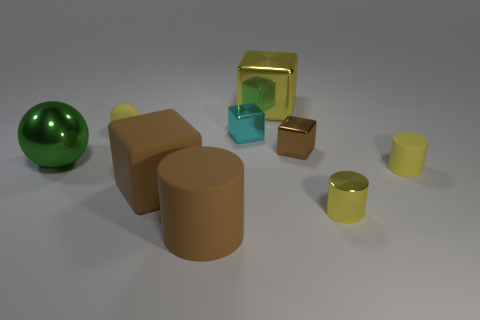Subtract all red cubes. Subtract all purple cylinders. How many cubes are left? 4 Add 1 small rubber objects. How many objects exist? 10 Subtract all cylinders. How many objects are left? 6 Add 2 brown shiny blocks. How many brown shiny blocks are left? 3 Add 2 green matte cylinders. How many green matte cylinders exist? 2 Subtract 0 red cylinders. How many objects are left? 9 Subtract all big gray rubber balls. Subtract all small cyan cubes. How many objects are left? 8 